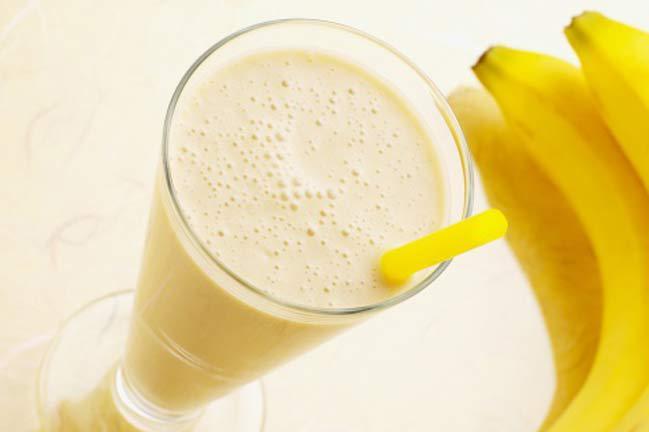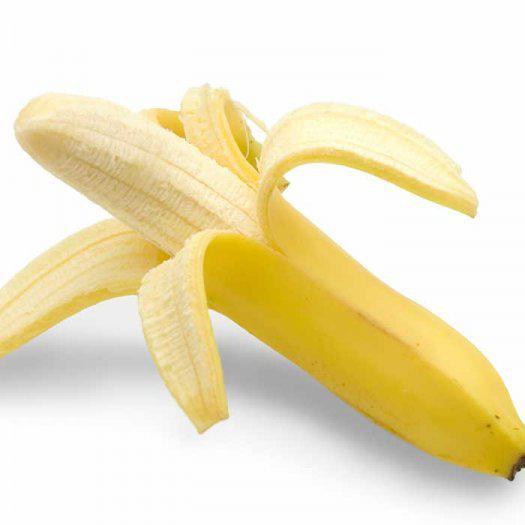The first image is the image on the left, the second image is the image on the right. For the images shown, is this caption "The left image includes unpeeled bananas with at least one other item, and the right image shows what is under a banana peel." true? Answer yes or no. Yes. The first image is the image on the left, the second image is the image on the right. Evaluate the accuracy of this statement regarding the images: "In one image, the inside of a banana is visible.". Is it true? Answer yes or no. Yes. 